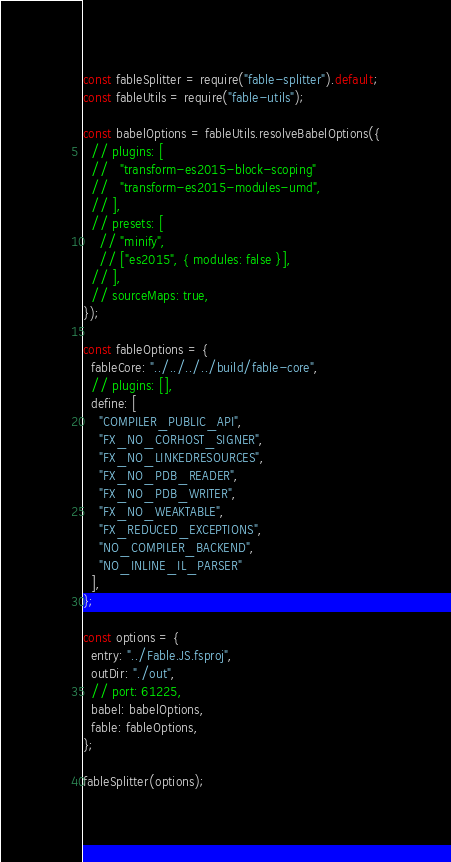<code> <loc_0><loc_0><loc_500><loc_500><_JavaScript_>const fableSplitter = require("fable-splitter").default;
const fableUtils = require("fable-utils");

const babelOptions = fableUtils.resolveBabelOptions({
  // plugins: [
  //   "transform-es2015-block-scoping"
  //   "transform-es2015-modules-umd",
  // ],
  // presets: [
    // "minify",
    // ["es2015", { modules: false }],
  // ],
  // sourceMaps: true,
});

const fableOptions = {
  fableCore: "../../../../build/fable-core",
  // plugins: [],
  define: [
    "COMPILER_PUBLIC_API",
    "FX_NO_CORHOST_SIGNER",
    "FX_NO_LINKEDRESOURCES",
    "FX_NO_PDB_READER",
    "FX_NO_PDB_WRITER",
    "FX_NO_WEAKTABLE",
    "FX_REDUCED_EXCEPTIONS",
    "NO_COMPILER_BACKEND",
    "NO_INLINE_IL_PARSER"
  ],
};

const options = {
  entry: "../Fable.JS.fsproj",
  outDir: "./out",
  // port: 61225,
  babel: babelOptions,
  fable: fableOptions,
};

fableSplitter(options);
</code> 